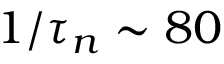<formula> <loc_0><loc_0><loc_500><loc_500>1 / \tau _ { n } \sim 8 0</formula> 